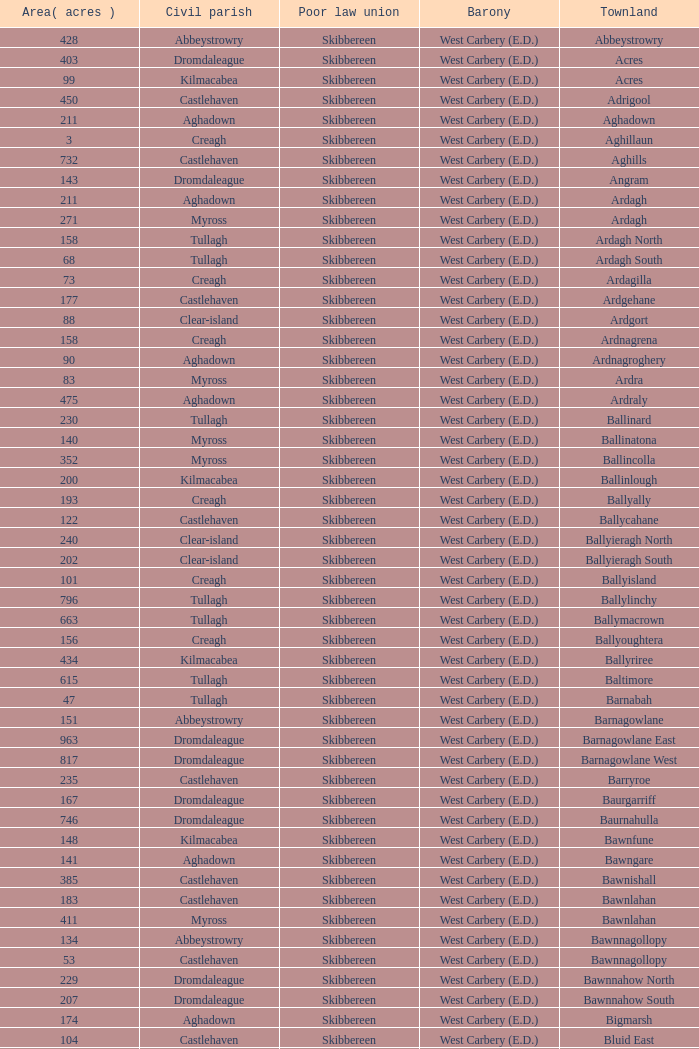What are the Baronies when the area (in acres) is 276? West Carbery (E.D.). 